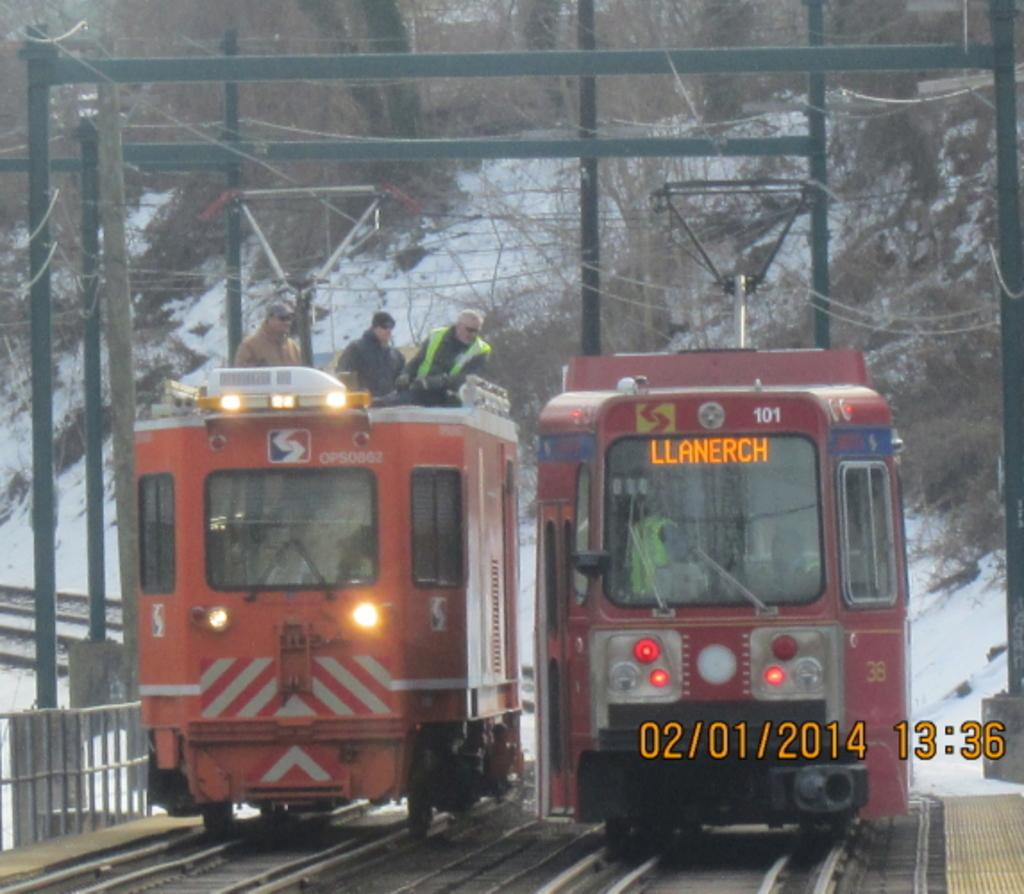<image>
Offer a succinct explanation of the picture presented. Twostreet railway cars side by side on tracks, one is heading to Llanerch 